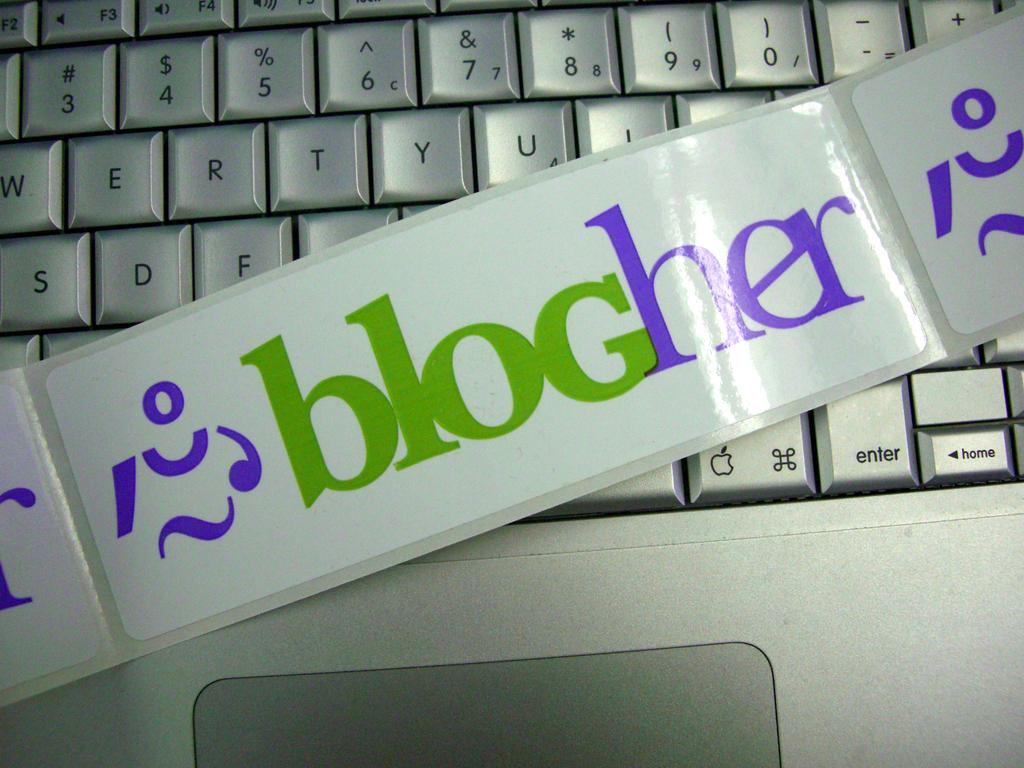Provide a one-sentence caption for the provided image. a banner reading blogher across a keyboard in white. 